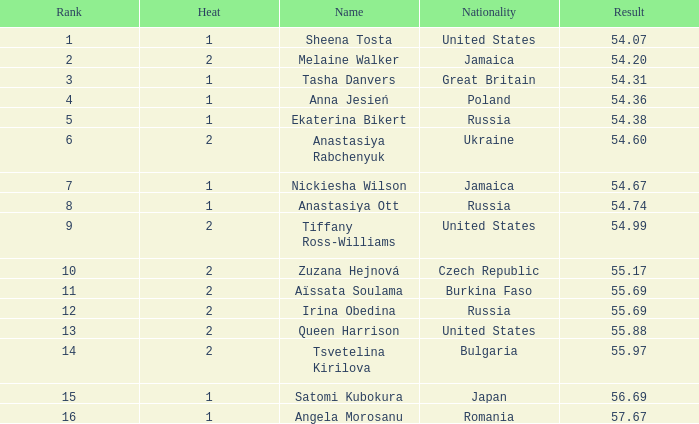Which group of citizens has a heat under 2, and a rank of 15? Japan. 